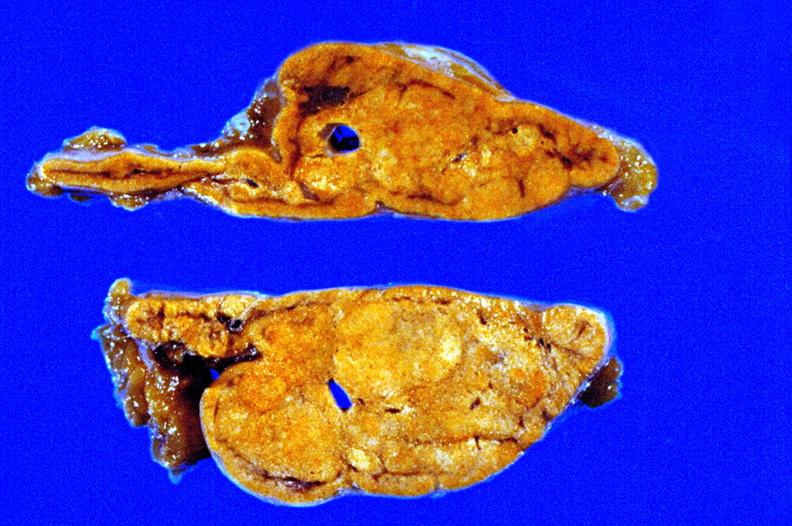where does this belong to?
Answer the question using a single word or phrase. Endocrine system 